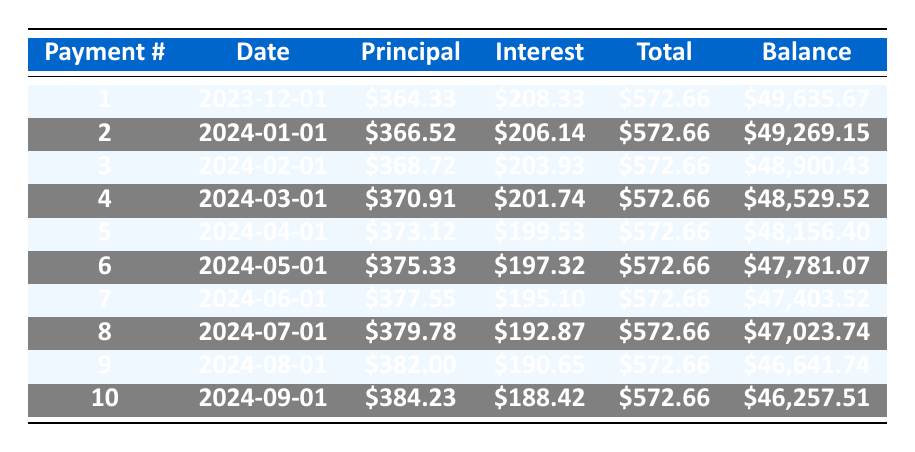What is the total payment for the first month? In the first row, under the "Total" column, the payment for the first month (Payment #1) is \$572.66.
Answer: \$572.66 How much of the payment in the second month goes toward the principal? In the second row, under the "Principal" column, the amount allocated for the principal payment (Payment #2) is \$366.52.
Answer: \$366.52 What is the remaining balance after the fifth payment? In the row for Payment #5, the "Balance" column shows the remaining balance after the fifth payment is \$48,156.40.
Answer: \$48,156.40 Is the principal payment for the third month greater than the principal payment for the first month? The principal payment for the third month (Payment #3) is \$368.72, and the first month (Payment #1) is \$364.33. Since 368.72 > 364.33, the statement is true.
Answer: Yes What is the total principal paid after the first two months? To find the total principal paid after the first two months, we sum the principal payments: \$364.33 (from Payment #1) + \$366.52 (from Payment #2) = \$730.85.
Answer: \$730.85 What is the average monthly payment over the first 10 months? The total payment for each month is \$572.66, over a period of 10 months: 10 * \$572.66 = \$5,726.60. Then, divide this by 10 to find the average: \$5,726.60 / 10 = \$572.66.
Answer: \$572.66 After how many months will the remaining balance be less than \$46,500? We assess the "Remaining Balance" column for each month and find that at Payment #9, the balance is \$46,641.74, and at Payment #10, it is \$46,257.51. Therefore, after Payment #10, the balance drops below \$46,500.
Answer: 10 months How much interest has been paid after four payments? The interest payment amounts for the first four payments are: \$208.33 (Payment #1), \$206.14 (Payment #2), \$203.93 (Payment #3), and \$201.74 (Payment #4). Summing these gives: \$208.33 + \$206.14 + \$203.93 + \$201.74 = \$820.14.
Answer: \$820.14 Is the interest payment for the eighth month less than \$190? The interest payment for the eighth month (Payment #8) is \$192.87, which is greater than \$190. Therefore, the answer is false.
Answer: No 